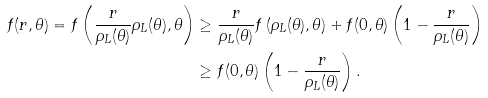<formula> <loc_0><loc_0><loc_500><loc_500>f ( r , \theta ) = f \left ( \frac { r } { \rho _ { L } ( \theta ) } \rho _ { L } ( \theta ) , \theta \right ) & \geq \frac { r } { \rho _ { L } ( \theta ) } f \left ( \rho _ { L } ( \theta ) , \theta \right ) + f ( 0 , \theta ) \left ( 1 - \frac { r } { \rho _ { L } ( \theta ) } \right ) \\ & \geq f ( 0 , \theta ) \left ( 1 - \frac { r } { \rho _ { L } ( \theta ) } \right ) .</formula> 